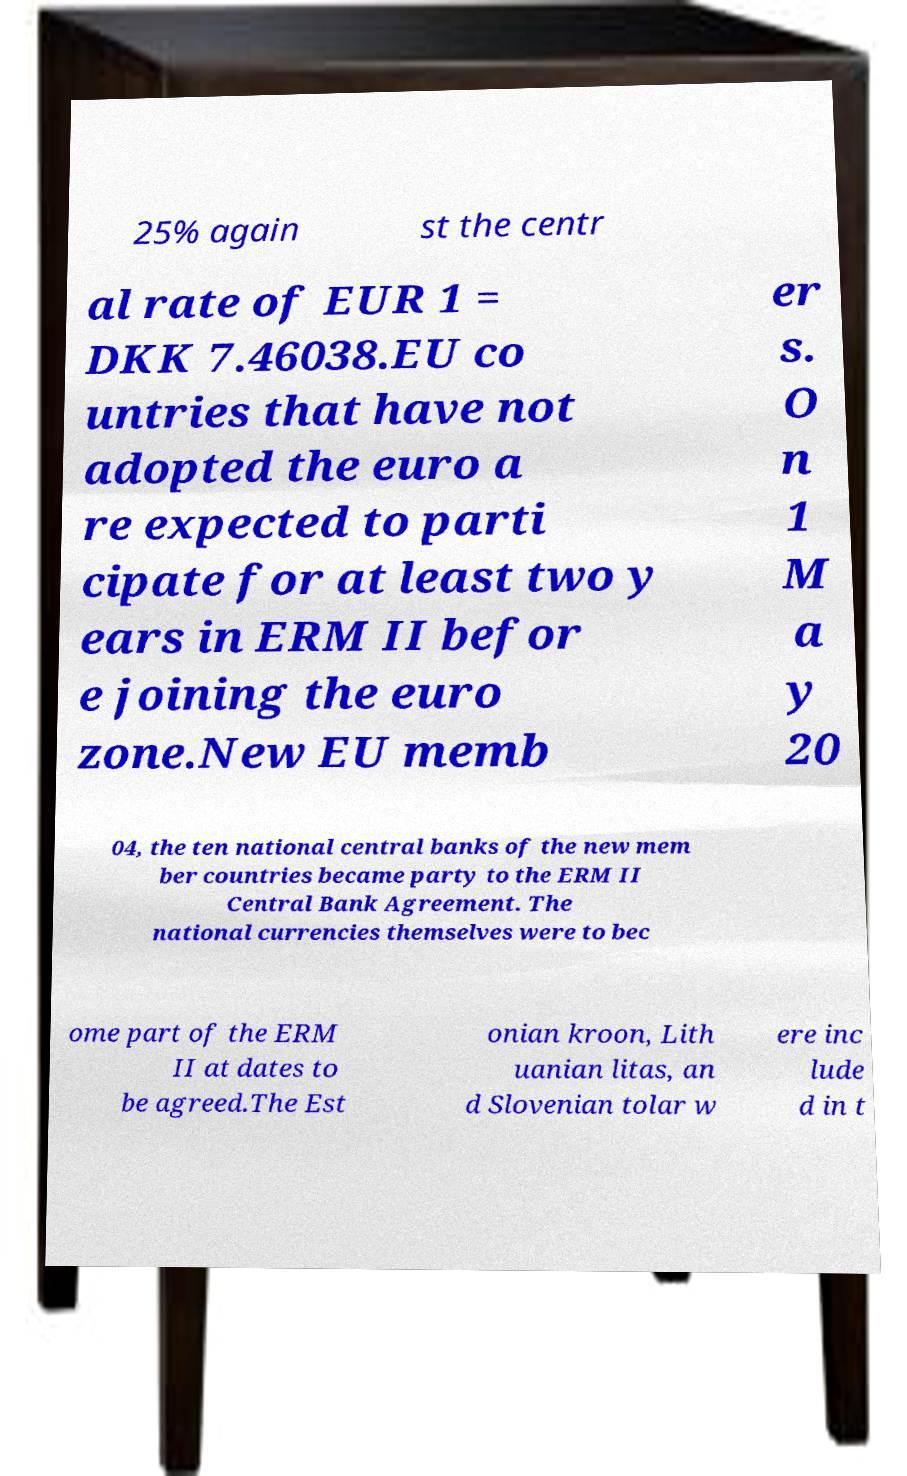Can you read and provide the text displayed in the image?This photo seems to have some interesting text. Can you extract and type it out for me? 25% again st the centr al rate of EUR 1 = DKK 7.46038.EU co untries that have not adopted the euro a re expected to parti cipate for at least two y ears in ERM II befor e joining the euro zone.New EU memb er s. O n 1 M a y 20 04, the ten national central banks of the new mem ber countries became party to the ERM II Central Bank Agreement. The national currencies themselves were to bec ome part of the ERM II at dates to be agreed.The Est onian kroon, Lith uanian litas, an d Slovenian tolar w ere inc lude d in t 